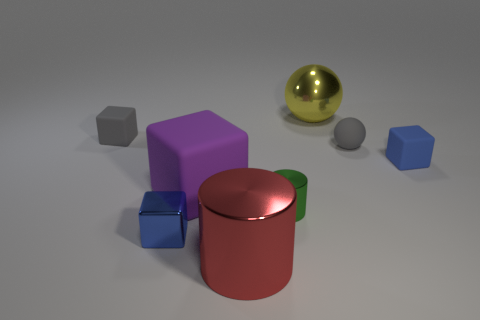What number of small gray things are in front of the gray thing to the left of the blue metal block? There is one small gray sphere located in front of the larger gray cube, which is positioned to the left of the blue metal block. 